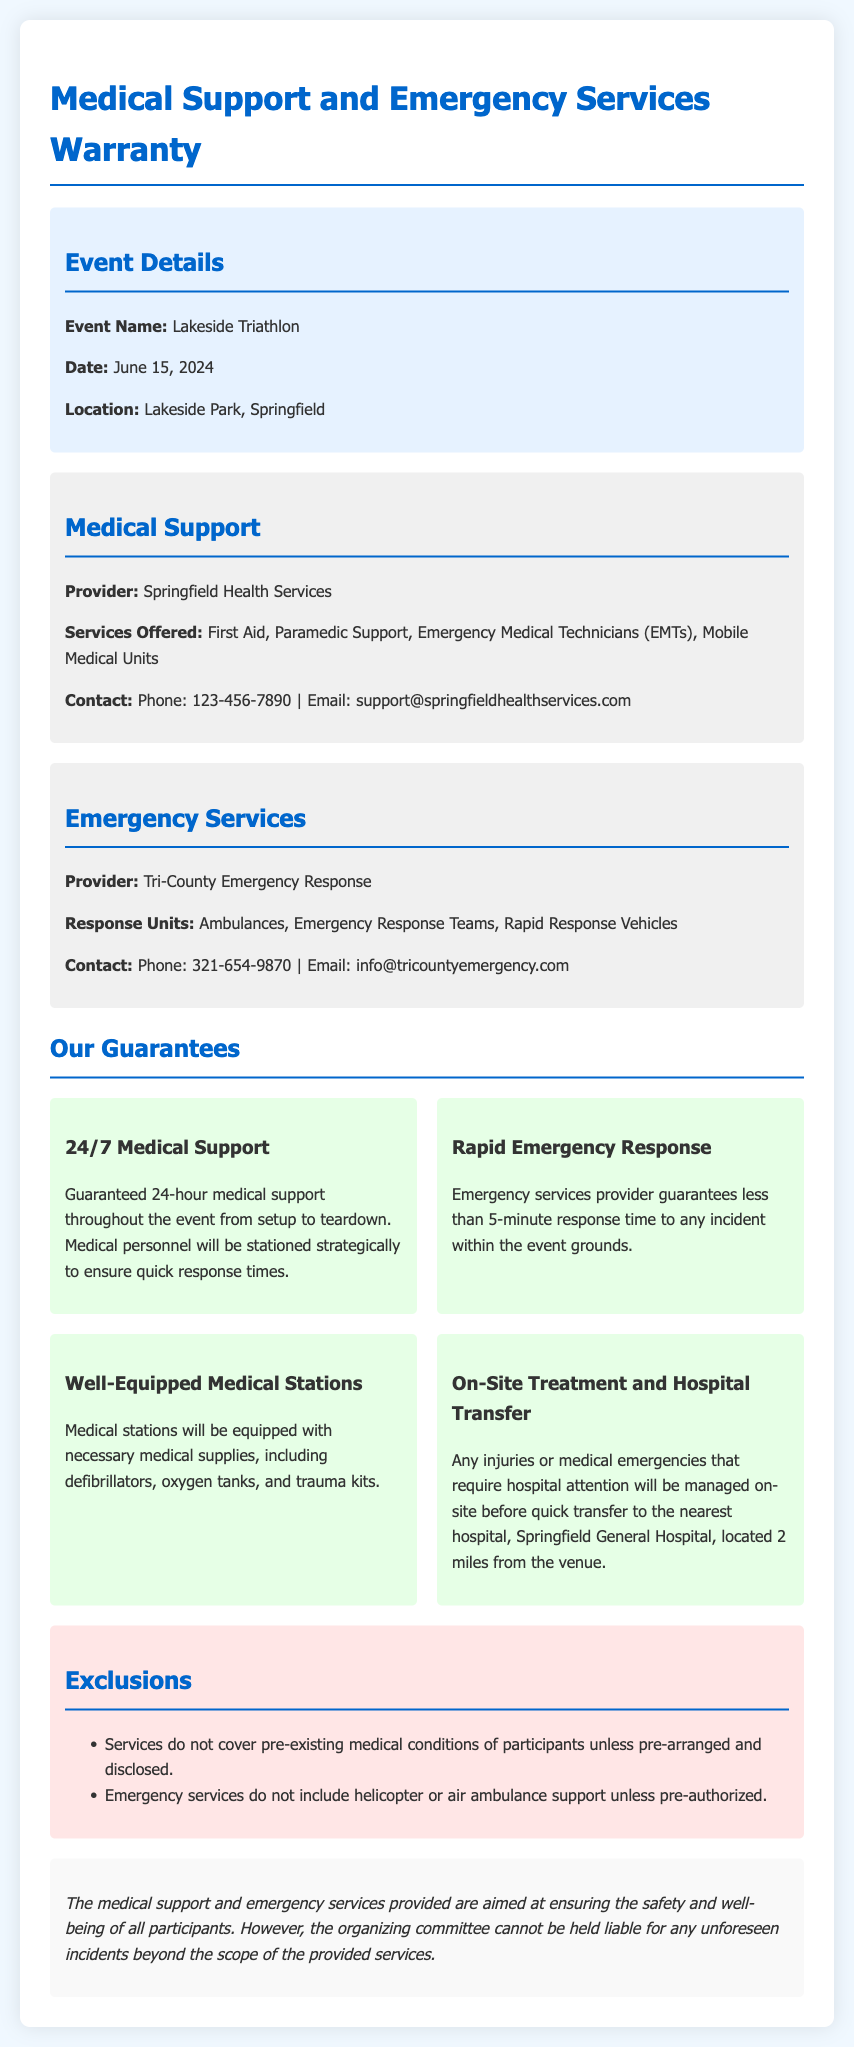What is the event name? The event name is explicitly mentioned in the document under Event Details.
Answer: Lakeside Triathlon Who provides medical support? The provider of medical support is stated in the Medical Support section of the document.
Answer: Springfield Health Services What is the response time guarantee for emergency services? The response time guarantee is clearly mentioned in the Our Guarantees section regarding emergency services.
Answer: less than 5 minutes Which hospital is designated for emergency transfers? The document specifies the hospital designated for emergency transfers in the On-Site Treatment and Hospital Transfer guarantee.
Answer: Springfield General Hospital What type of services does Tri-County Emergency Response provide? The services provided are listed in the Emergency Services section of the document.
Answer: Ambulances, Emergency Response Teams, Rapid Response Vehicles What are the exclusions regarding pre-existing conditions? The exclusions section mentions specific exclusions related to pre-existing conditions of participants.
Answer: Pre-existing medical conditions How many types of medical supply equipment are mentioned in the well-equipped medical stations? The Well-Equipped Medical Stations guarantee lists the necessary medical supplies as part of the explanation.
Answer: three 